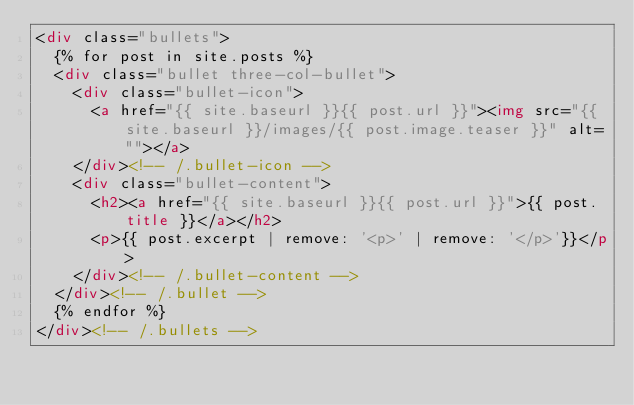Convert code to text. <code><loc_0><loc_0><loc_500><loc_500><_HTML_><div class="bullets">
	{% for post in site.posts %}
	<div class="bullet three-col-bullet">
		<div class="bullet-icon">
			<a href="{{ site.baseurl }}{{ post.url }}"><img src="{{ site.baseurl }}/images/{{ post.image.teaser }}" alt=""></a>
		</div><!-- /.bullet-icon -->
		<div class="bullet-content">
			<h2><a href="{{ site.baseurl }}{{ post.url }}">{{ post.title }}</a></h2>
			<p>{{ post.excerpt | remove: '<p>' | remove: '</p>'}}</p>
		</div><!-- /.bullet-content -->
	</div><!-- /.bullet -->
	{% endfor %}
</div><!-- /.bullets -->
</code> 